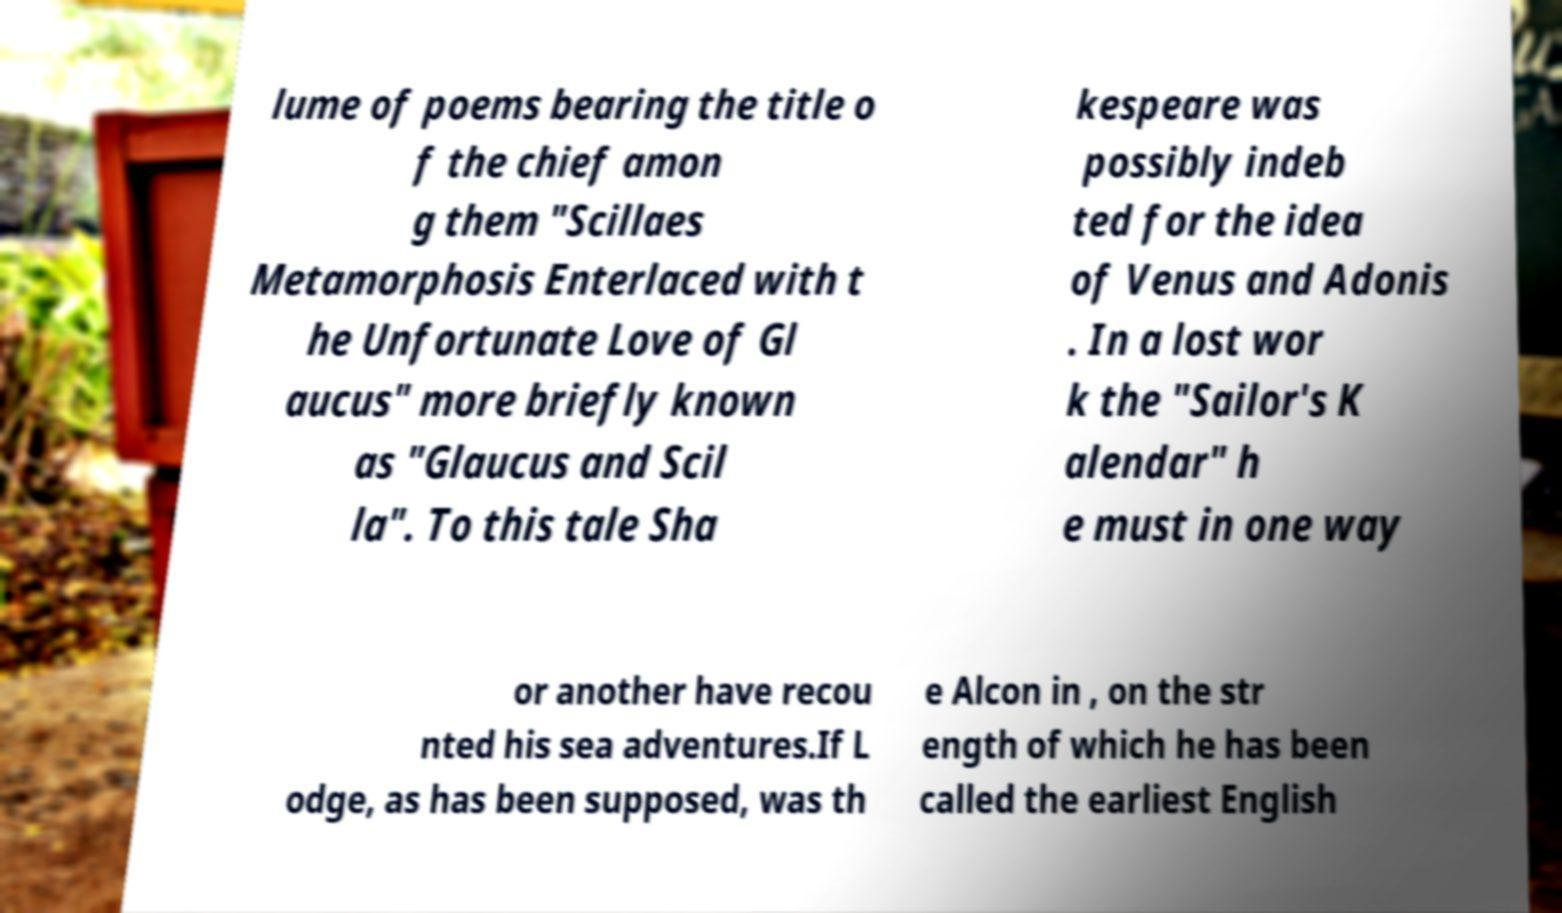I need the written content from this picture converted into text. Can you do that? lume of poems bearing the title o f the chief amon g them "Scillaes Metamorphosis Enterlaced with t he Unfortunate Love of Gl aucus" more briefly known as "Glaucus and Scil la". To this tale Sha kespeare was possibly indeb ted for the idea of Venus and Adonis . In a lost wor k the "Sailor's K alendar" h e must in one way or another have recou nted his sea adventures.If L odge, as has been supposed, was th e Alcon in , on the str ength of which he has been called the earliest English 